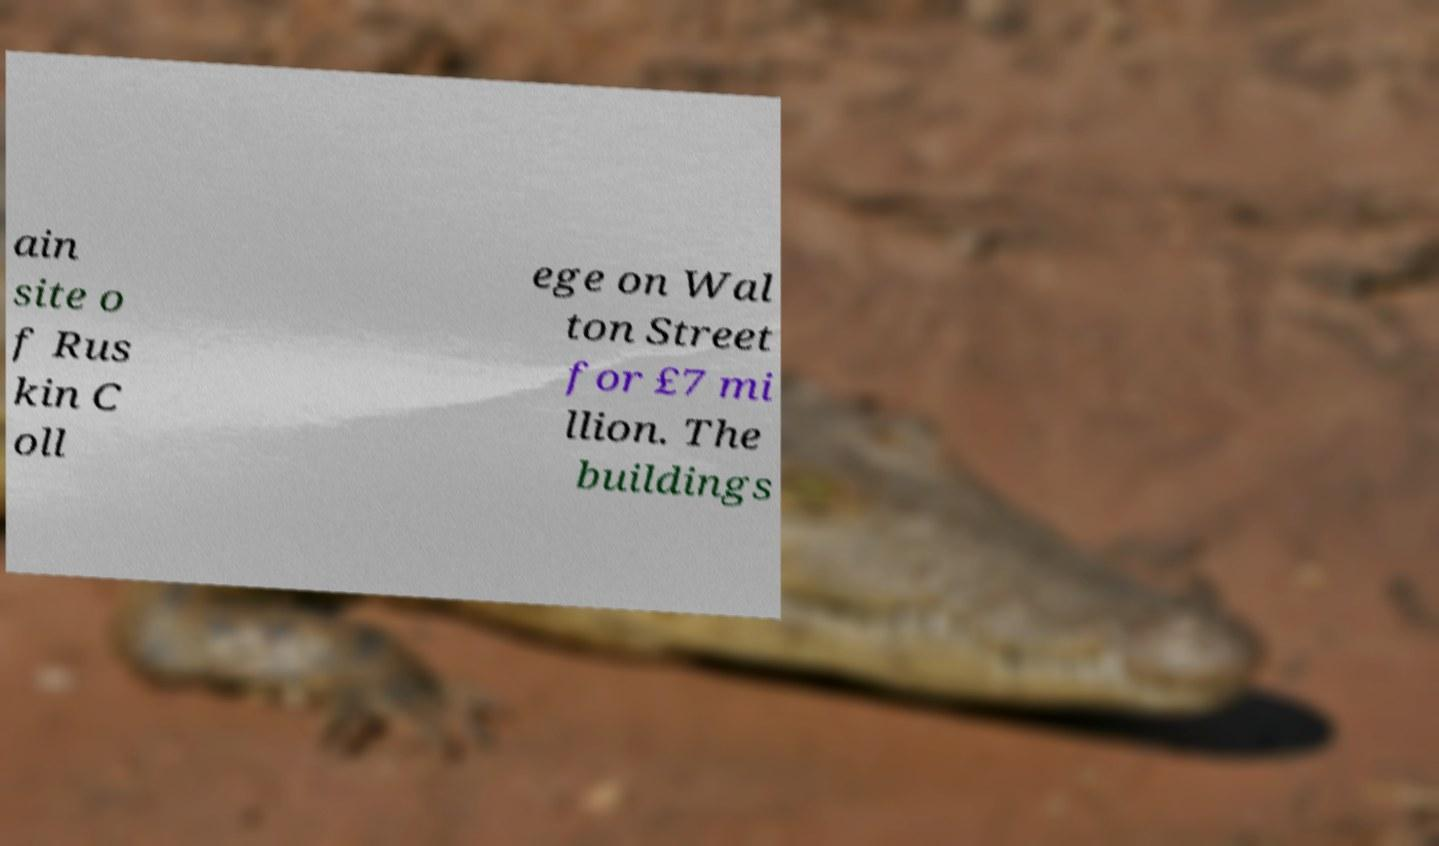Can you accurately transcribe the text from the provided image for me? ain site o f Rus kin C oll ege on Wal ton Street for £7 mi llion. The buildings 